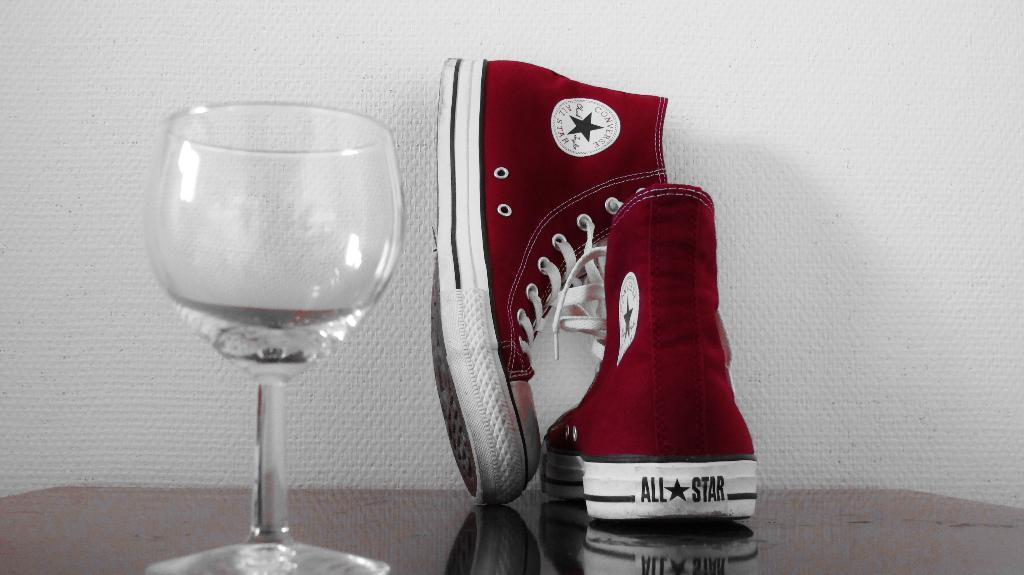What type of footwear is visible in the image? There are shoes in the image. What other object can be seen in the image besides the shoes? There is a glass visible in the image. Where are the shoes and glass located? The shoes and glass are on a table. What is visible in the background of the image? There is a wall in the background of the image. What type of vase is visible on the elbow of the person in the image? There is no vase or person present in the image. How does the aunt interact with the shoes in the image? There is no aunt present in the image, and therefore no interaction with the shoes can be observed. 